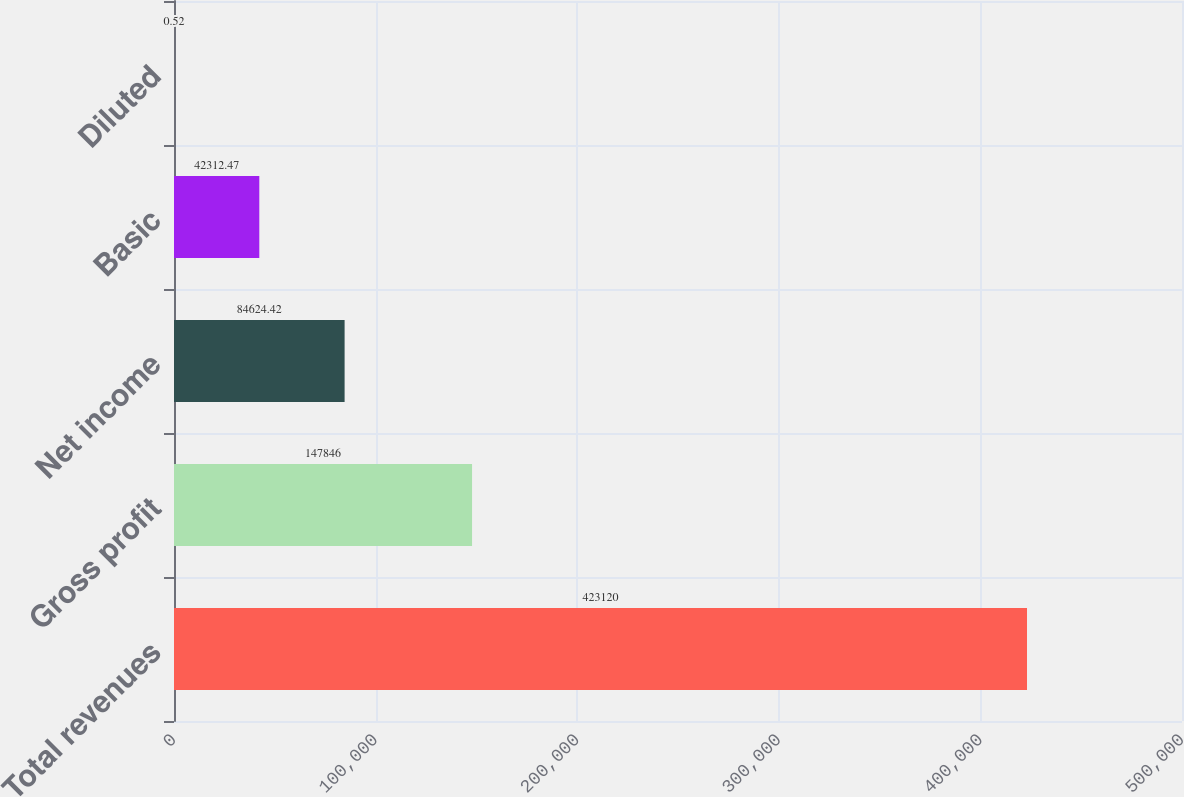<chart> <loc_0><loc_0><loc_500><loc_500><bar_chart><fcel>Total revenues<fcel>Gross profit<fcel>Net income<fcel>Basic<fcel>Diluted<nl><fcel>423120<fcel>147846<fcel>84624.4<fcel>42312.5<fcel>0.52<nl></chart> 